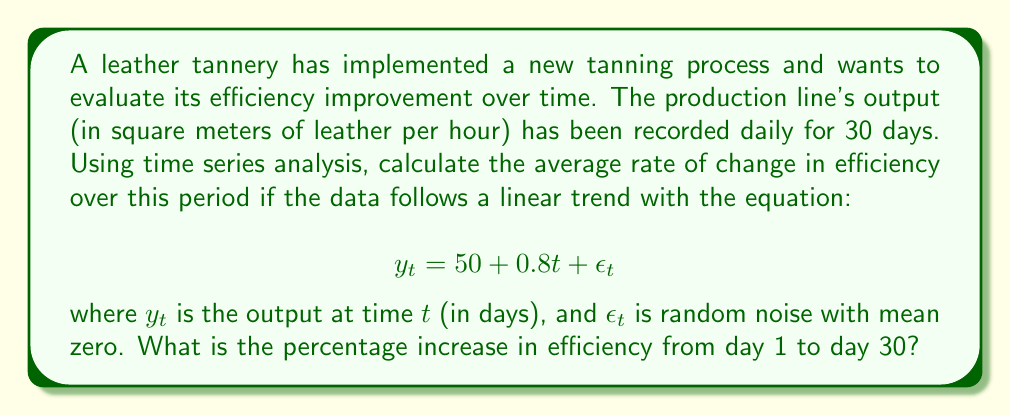Can you solve this math problem? To solve this problem, we'll follow these steps:

1. Identify the linear trend equation:
   The given equation $y_t = 50 + 0.8t + \epsilon_t$ represents a linear trend where:
   - 50 is the initial output (intercept)
   - 0.8 is the daily rate of increase (slope)
   - $\epsilon_t$ is random noise with mean zero, which we can ignore for trend analysis

2. Calculate the average rate of change:
   The slope of the line, 0.8, represents the average daily increase in output. This is our average rate of change in efficiency.

3. Calculate the output on day 1 and day 30:
   - Day 1: $y_1 = 50 + 0.8(1) = 50.8$ sq meters/hour
   - Day 30: $y_{30} = 50 + 0.8(30) = 74$ sq meters/hour

4. Calculate the total increase from day 1 to day 30:
   $\text{Increase} = y_{30} - y_1 = 74 - 50.8 = 23.2$ sq meters/hour

5. Calculate the percentage increase:
   $$\text{Percentage increase} = \frac{\text{Increase}}{\text{Initial value}} \times 100\%$$
   $$= \frac{23.2}{50.8} \times 100\% = 45.67\%$$

Thus, the efficiency of the leather production line increased by approximately 45.67% from day 1 to day 30.
Answer: The average rate of change in efficiency is 0.8 square meters per hour per day, and the percentage increase in efficiency from day 1 to day 30 is 45.67%. 